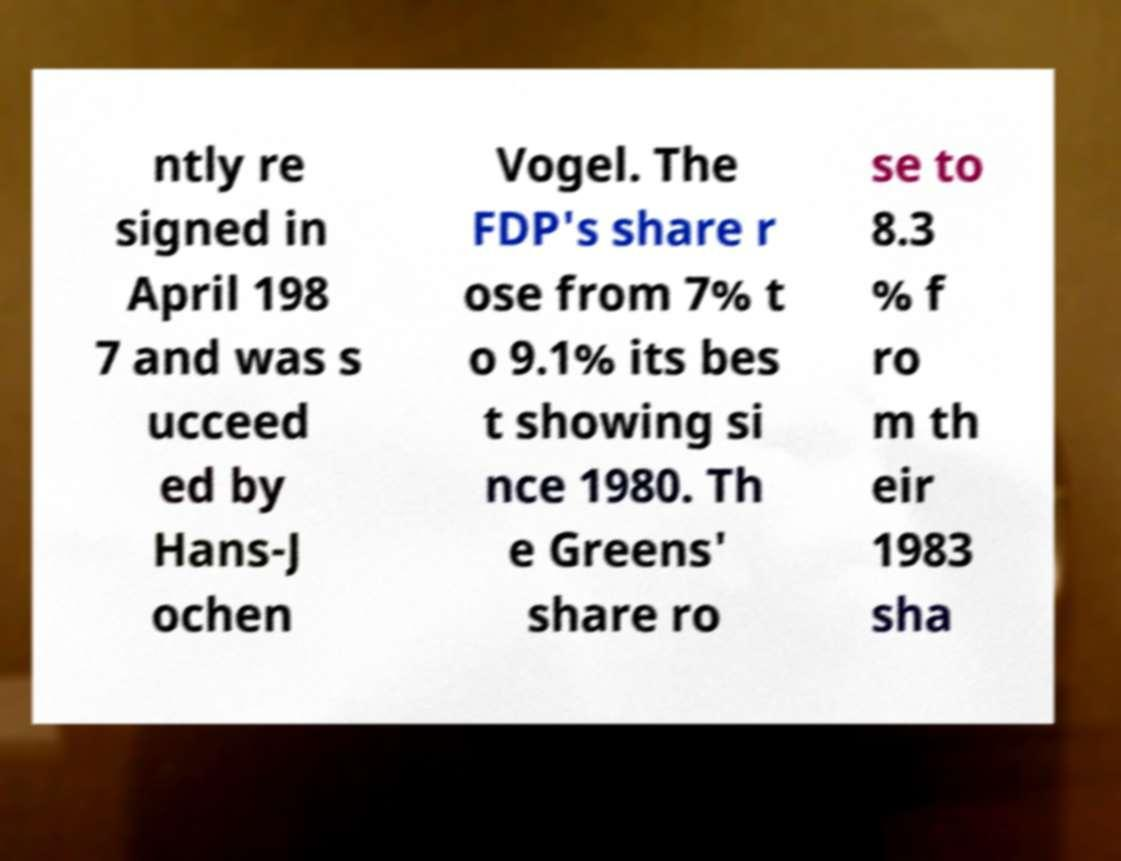Please read and relay the text visible in this image. What does it say? ntly re signed in April 198 7 and was s ucceed ed by Hans-J ochen Vogel. The FDP's share r ose from 7% t o 9.1% its bes t showing si nce 1980. Th e Greens' share ro se to 8.3 % f ro m th eir 1983 sha 